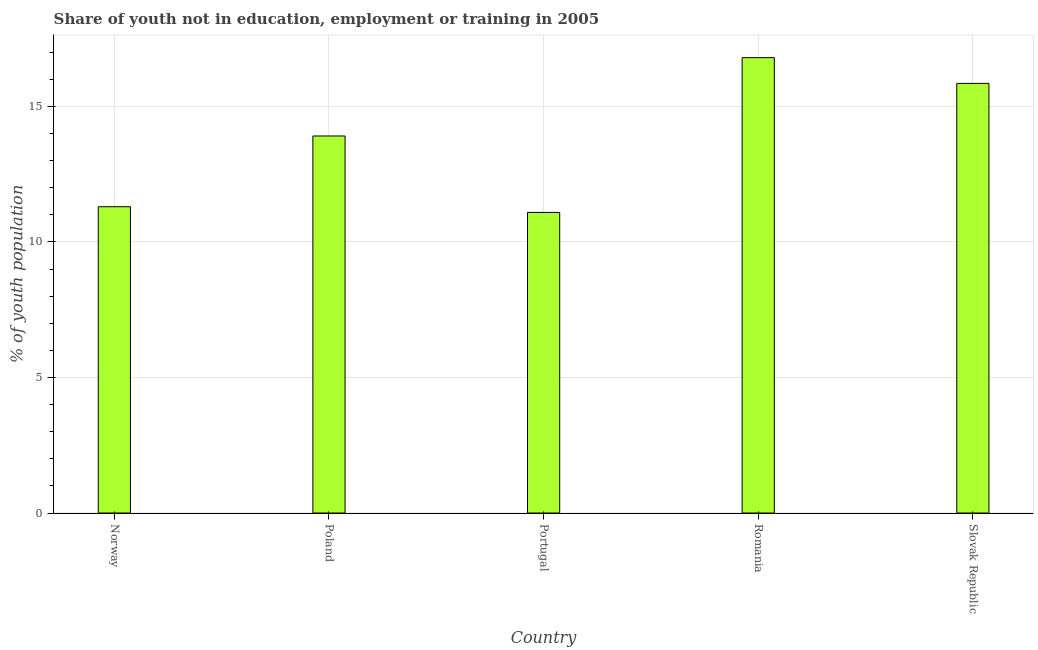Does the graph contain any zero values?
Your response must be concise. No. Does the graph contain grids?
Provide a succinct answer. Yes. What is the title of the graph?
Ensure brevity in your answer.  Share of youth not in education, employment or training in 2005. What is the label or title of the Y-axis?
Your answer should be very brief. % of youth population. What is the unemployed youth population in Slovak Republic?
Offer a terse response. 15.85. Across all countries, what is the maximum unemployed youth population?
Provide a short and direct response. 16.8. Across all countries, what is the minimum unemployed youth population?
Your answer should be compact. 11.09. In which country was the unemployed youth population maximum?
Keep it short and to the point. Romania. In which country was the unemployed youth population minimum?
Keep it short and to the point. Portugal. What is the sum of the unemployed youth population?
Keep it short and to the point. 68.95. What is the difference between the unemployed youth population in Poland and Slovak Republic?
Your response must be concise. -1.94. What is the average unemployed youth population per country?
Keep it short and to the point. 13.79. What is the median unemployed youth population?
Ensure brevity in your answer.  13.91. In how many countries, is the unemployed youth population greater than 1 %?
Make the answer very short. 5. What is the ratio of the unemployed youth population in Romania to that in Slovak Republic?
Provide a succinct answer. 1.06. Is the difference between the unemployed youth population in Poland and Romania greater than the difference between any two countries?
Your answer should be compact. No. What is the difference between the highest and the second highest unemployed youth population?
Ensure brevity in your answer.  0.95. Is the sum of the unemployed youth population in Poland and Portugal greater than the maximum unemployed youth population across all countries?
Your answer should be very brief. Yes. What is the difference between the highest and the lowest unemployed youth population?
Offer a very short reply. 5.71. Are all the bars in the graph horizontal?
Keep it short and to the point. No. How many countries are there in the graph?
Ensure brevity in your answer.  5. Are the values on the major ticks of Y-axis written in scientific E-notation?
Provide a short and direct response. No. What is the % of youth population of Norway?
Offer a terse response. 11.3. What is the % of youth population in Poland?
Keep it short and to the point. 13.91. What is the % of youth population of Portugal?
Your response must be concise. 11.09. What is the % of youth population of Romania?
Offer a very short reply. 16.8. What is the % of youth population in Slovak Republic?
Your answer should be very brief. 15.85. What is the difference between the % of youth population in Norway and Poland?
Your response must be concise. -2.61. What is the difference between the % of youth population in Norway and Portugal?
Offer a terse response. 0.21. What is the difference between the % of youth population in Norway and Romania?
Provide a succinct answer. -5.5. What is the difference between the % of youth population in Norway and Slovak Republic?
Your answer should be very brief. -4.55. What is the difference between the % of youth population in Poland and Portugal?
Offer a very short reply. 2.82. What is the difference between the % of youth population in Poland and Romania?
Ensure brevity in your answer.  -2.89. What is the difference between the % of youth population in Poland and Slovak Republic?
Offer a terse response. -1.94. What is the difference between the % of youth population in Portugal and Romania?
Provide a short and direct response. -5.71. What is the difference between the % of youth population in Portugal and Slovak Republic?
Your answer should be very brief. -4.76. What is the ratio of the % of youth population in Norway to that in Poland?
Give a very brief answer. 0.81. What is the ratio of the % of youth population in Norway to that in Romania?
Offer a terse response. 0.67. What is the ratio of the % of youth population in Norway to that in Slovak Republic?
Keep it short and to the point. 0.71. What is the ratio of the % of youth population in Poland to that in Portugal?
Make the answer very short. 1.25. What is the ratio of the % of youth population in Poland to that in Romania?
Provide a short and direct response. 0.83. What is the ratio of the % of youth population in Poland to that in Slovak Republic?
Offer a very short reply. 0.88. What is the ratio of the % of youth population in Portugal to that in Romania?
Offer a very short reply. 0.66. What is the ratio of the % of youth population in Portugal to that in Slovak Republic?
Provide a short and direct response. 0.7. What is the ratio of the % of youth population in Romania to that in Slovak Republic?
Ensure brevity in your answer.  1.06. 